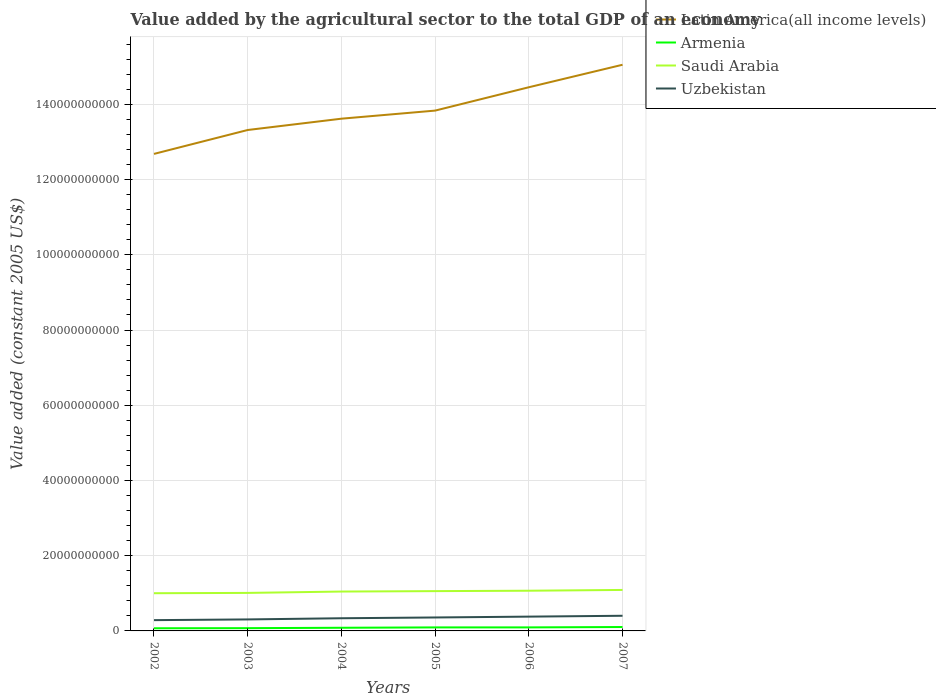Does the line corresponding to Saudi Arabia intersect with the line corresponding to Uzbekistan?
Your answer should be compact. No. Across all years, what is the maximum value added by the agricultural sector in Armenia?
Provide a succinct answer. 7.05e+08. In which year was the value added by the agricultural sector in Latin America(all income levels) maximum?
Your response must be concise. 2002. What is the total value added by the agricultural sector in Armenia in the graph?
Give a very brief answer. -9.48e+07. What is the difference between the highest and the second highest value added by the agricultural sector in Latin America(all income levels)?
Your answer should be compact. 2.37e+1. What is the difference between the highest and the lowest value added by the agricultural sector in Uzbekistan?
Ensure brevity in your answer.  3. Is the value added by the agricultural sector in Saudi Arabia strictly greater than the value added by the agricultural sector in Uzbekistan over the years?
Provide a short and direct response. No. What is the difference between two consecutive major ticks on the Y-axis?
Keep it short and to the point. 2.00e+1. Does the graph contain grids?
Your answer should be very brief. Yes. What is the title of the graph?
Keep it short and to the point. Value added by the agricultural sector to the total GDP of an economy. What is the label or title of the Y-axis?
Keep it short and to the point. Value added (constant 2005 US$). What is the Value added (constant 2005 US$) of Latin America(all income levels) in 2002?
Provide a short and direct response. 1.27e+11. What is the Value added (constant 2005 US$) in Armenia in 2002?
Provide a short and direct response. 7.05e+08. What is the Value added (constant 2005 US$) in Saudi Arabia in 2002?
Offer a very short reply. 1.00e+1. What is the Value added (constant 2005 US$) in Uzbekistan in 2002?
Offer a very short reply. 2.86e+09. What is the Value added (constant 2005 US$) of Latin America(all income levels) in 2003?
Give a very brief answer. 1.33e+11. What is the Value added (constant 2005 US$) in Armenia in 2003?
Your answer should be very brief. 7.34e+08. What is the Value added (constant 2005 US$) of Saudi Arabia in 2003?
Offer a terse response. 1.01e+1. What is the Value added (constant 2005 US$) of Uzbekistan in 2003?
Your answer should be compact. 3.06e+09. What is the Value added (constant 2005 US$) in Latin America(all income levels) in 2004?
Your answer should be compact. 1.36e+11. What is the Value added (constant 2005 US$) of Armenia in 2004?
Your response must be concise. 8.41e+08. What is the Value added (constant 2005 US$) in Saudi Arabia in 2004?
Offer a terse response. 1.05e+1. What is the Value added (constant 2005 US$) of Uzbekistan in 2004?
Provide a short and direct response. 3.37e+09. What is the Value added (constant 2005 US$) in Latin America(all income levels) in 2005?
Give a very brief answer. 1.38e+11. What is the Value added (constant 2005 US$) of Armenia in 2005?
Ensure brevity in your answer.  9.36e+08. What is the Value added (constant 2005 US$) of Saudi Arabia in 2005?
Provide a succinct answer. 1.06e+1. What is the Value added (constant 2005 US$) in Uzbekistan in 2005?
Keep it short and to the point. 3.58e+09. What is the Value added (constant 2005 US$) in Latin America(all income levels) in 2006?
Provide a short and direct response. 1.45e+11. What is the Value added (constant 2005 US$) in Armenia in 2006?
Give a very brief answer. 9.40e+08. What is the Value added (constant 2005 US$) in Saudi Arabia in 2006?
Provide a short and direct response. 1.07e+1. What is the Value added (constant 2005 US$) of Uzbekistan in 2006?
Give a very brief answer. 3.80e+09. What is the Value added (constant 2005 US$) in Latin America(all income levels) in 2007?
Give a very brief answer. 1.51e+11. What is the Value added (constant 2005 US$) of Armenia in 2007?
Your response must be concise. 1.04e+09. What is the Value added (constant 2005 US$) of Saudi Arabia in 2007?
Your answer should be compact. 1.09e+1. What is the Value added (constant 2005 US$) of Uzbekistan in 2007?
Give a very brief answer. 4.03e+09. Across all years, what is the maximum Value added (constant 2005 US$) in Latin America(all income levels)?
Your answer should be very brief. 1.51e+11. Across all years, what is the maximum Value added (constant 2005 US$) in Armenia?
Offer a terse response. 1.04e+09. Across all years, what is the maximum Value added (constant 2005 US$) of Saudi Arabia?
Give a very brief answer. 1.09e+1. Across all years, what is the maximum Value added (constant 2005 US$) in Uzbekistan?
Provide a short and direct response. 4.03e+09. Across all years, what is the minimum Value added (constant 2005 US$) in Latin America(all income levels)?
Offer a very short reply. 1.27e+11. Across all years, what is the minimum Value added (constant 2005 US$) in Armenia?
Give a very brief answer. 7.05e+08. Across all years, what is the minimum Value added (constant 2005 US$) in Saudi Arabia?
Keep it short and to the point. 1.00e+1. Across all years, what is the minimum Value added (constant 2005 US$) of Uzbekistan?
Ensure brevity in your answer.  2.86e+09. What is the total Value added (constant 2005 US$) of Latin America(all income levels) in the graph?
Give a very brief answer. 8.30e+11. What is the total Value added (constant 2005 US$) in Armenia in the graph?
Your response must be concise. 5.19e+09. What is the total Value added (constant 2005 US$) in Saudi Arabia in the graph?
Your answer should be very brief. 6.28e+1. What is the total Value added (constant 2005 US$) of Uzbekistan in the graph?
Provide a short and direct response. 2.07e+1. What is the difference between the Value added (constant 2005 US$) in Latin America(all income levels) in 2002 and that in 2003?
Keep it short and to the point. -6.36e+09. What is the difference between the Value added (constant 2005 US$) in Armenia in 2002 and that in 2003?
Your response must be concise. -2.97e+07. What is the difference between the Value added (constant 2005 US$) in Saudi Arabia in 2002 and that in 2003?
Keep it short and to the point. -8.17e+07. What is the difference between the Value added (constant 2005 US$) of Uzbekistan in 2002 and that in 2003?
Keep it short and to the point. -1.95e+08. What is the difference between the Value added (constant 2005 US$) in Latin America(all income levels) in 2002 and that in 2004?
Offer a terse response. -9.36e+09. What is the difference between the Value added (constant 2005 US$) in Armenia in 2002 and that in 2004?
Your answer should be compact. -1.36e+08. What is the difference between the Value added (constant 2005 US$) of Saudi Arabia in 2002 and that in 2004?
Keep it short and to the point. -4.44e+08. What is the difference between the Value added (constant 2005 US$) in Uzbekistan in 2002 and that in 2004?
Your response must be concise. -5.04e+08. What is the difference between the Value added (constant 2005 US$) of Latin America(all income levels) in 2002 and that in 2005?
Make the answer very short. -1.15e+1. What is the difference between the Value added (constant 2005 US$) in Armenia in 2002 and that in 2005?
Offer a very short reply. -2.31e+08. What is the difference between the Value added (constant 2005 US$) of Saudi Arabia in 2002 and that in 2005?
Provide a succinct answer. -5.55e+08. What is the difference between the Value added (constant 2005 US$) in Uzbekistan in 2002 and that in 2005?
Give a very brief answer. -7.13e+08. What is the difference between the Value added (constant 2005 US$) of Latin America(all income levels) in 2002 and that in 2006?
Your answer should be compact. -1.77e+1. What is the difference between the Value added (constant 2005 US$) of Armenia in 2002 and that in 2006?
Your answer should be compact. -2.36e+08. What is the difference between the Value added (constant 2005 US$) in Saudi Arabia in 2002 and that in 2006?
Provide a succinct answer. -6.62e+08. What is the difference between the Value added (constant 2005 US$) in Uzbekistan in 2002 and that in 2006?
Give a very brief answer. -9.34e+08. What is the difference between the Value added (constant 2005 US$) in Latin America(all income levels) in 2002 and that in 2007?
Offer a terse response. -2.37e+1. What is the difference between the Value added (constant 2005 US$) in Armenia in 2002 and that in 2007?
Your answer should be compact. -3.33e+08. What is the difference between the Value added (constant 2005 US$) of Saudi Arabia in 2002 and that in 2007?
Provide a short and direct response. -8.70e+08. What is the difference between the Value added (constant 2005 US$) of Uzbekistan in 2002 and that in 2007?
Give a very brief answer. -1.17e+09. What is the difference between the Value added (constant 2005 US$) of Latin America(all income levels) in 2003 and that in 2004?
Keep it short and to the point. -3.01e+09. What is the difference between the Value added (constant 2005 US$) in Armenia in 2003 and that in 2004?
Provide a short and direct response. -1.07e+08. What is the difference between the Value added (constant 2005 US$) in Saudi Arabia in 2003 and that in 2004?
Your answer should be compact. -3.63e+08. What is the difference between the Value added (constant 2005 US$) of Uzbekistan in 2003 and that in 2004?
Your answer should be very brief. -3.09e+08. What is the difference between the Value added (constant 2005 US$) of Latin America(all income levels) in 2003 and that in 2005?
Give a very brief answer. -5.16e+09. What is the difference between the Value added (constant 2005 US$) of Armenia in 2003 and that in 2005?
Keep it short and to the point. -2.02e+08. What is the difference between the Value added (constant 2005 US$) in Saudi Arabia in 2003 and that in 2005?
Offer a very short reply. -4.74e+08. What is the difference between the Value added (constant 2005 US$) of Uzbekistan in 2003 and that in 2005?
Keep it short and to the point. -5.18e+08. What is the difference between the Value added (constant 2005 US$) of Latin America(all income levels) in 2003 and that in 2006?
Provide a short and direct response. -1.14e+1. What is the difference between the Value added (constant 2005 US$) of Armenia in 2003 and that in 2006?
Your answer should be very brief. -2.06e+08. What is the difference between the Value added (constant 2005 US$) of Saudi Arabia in 2003 and that in 2006?
Offer a very short reply. -5.80e+08. What is the difference between the Value added (constant 2005 US$) of Uzbekistan in 2003 and that in 2006?
Make the answer very short. -7.40e+08. What is the difference between the Value added (constant 2005 US$) of Latin America(all income levels) in 2003 and that in 2007?
Offer a very short reply. -1.73e+1. What is the difference between the Value added (constant 2005 US$) of Armenia in 2003 and that in 2007?
Keep it short and to the point. -3.03e+08. What is the difference between the Value added (constant 2005 US$) in Saudi Arabia in 2003 and that in 2007?
Your answer should be compact. -7.89e+08. What is the difference between the Value added (constant 2005 US$) of Uzbekistan in 2003 and that in 2007?
Offer a very short reply. -9.71e+08. What is the difference between the Value added (constant 2005 US$) of Latin America(all income levels) in 2004 and that in 2005?
Your answer should be very brief. -2.15e+09. What is the difference between the Value added (constant 2005 US$) in Armenia in 2004 and that in 2005?
Provide a short and direct response. -9.48e+07. What is the difference between the Value added (constant 2005 US$) of Saudi Arabia in 2004 and that in 2005?
Give a very brief answer. -1.11e+08. What is the difference between the Value added (constant 2005 US$) of Uzbekistan in 2004 and that in 2005?
Provide a short and direct response. -2.09e+08. What is the difference between the Value added (constant 2005 US$) in Latin America(all income levels) in 2004 and that in 2006?
Offer a very short reply. -8.36e+09. What is the difference between the Value added (constant 2005 US$) of Armenia in 2004 and that in 2006?
Keep it short and to the point. -9.94e+07. What is the difference between the Value added (constant 2005 US$) in Saudi Arabia in 2004 and that in 2006?
Offer a very short reply. -2.18e+08. What is the difference between the Value added (constant 2005 US$) of Uzbekistan in 2004 and that in 2006?
Your answer should be very brief. -4.31e+08. What is the difference between the Value added (constant 2005 US$) of Latin America(all income levels) in 2004 and that in 2007?
Your answer should be compact. -1.43e+1. What is the difference between the Value added (constant 2005 US$) of Armenia in 2004 and that in 2007?
Provide a succinct answer. -1.96e+08. What is the difference between the Value added (constant 2005 US$) in Saudi Arabia in 2004 and that in 2007?
Keep it short and to the point. -4.26e+08. What is the difference between the Value added (constant 2005 US$) of Uzbekistan in 2004 and that in 2007?
Your answer should be compact. -6.62e+08. What is the difference between the Value added (constant 2005 US$) of Latin America(all income levels) in 2005 and that in 2006?
Your response must be concise. -6.21e+09. What is the difference between the Value added (constant 2005 US$) in Armenia in 2005 and that in 2006?
Ensure brevity in your answer.  -4.53e+06. What is the difference between the Value added (constant 2005 US$) in Saudi Arabia in 2005 and that in 2006?
Offer a very short reply. -1.07e+08. What is the difference between the Value added (constant 2005 US$) in Uzbekistan in 2005 and that in 2006?
Provide a short and direct response. -2.22e+08. What is the difference between the Value added (constant 2005 US$) in Latin America(all income levels) in 2005 and that in 2007?
Your answer should be very brief. -1.22e+1. What is the difference between the Value added (constant 2005 US$) of Armenia in 2005 and that in 2007?
Ensure brevity in your answer.  -1.01e+08. What is the difference between the Value added (constant 2005 US$) in Saudi Arabia in 2005 and that in 2007?
Offer a terse response. -3.15e+08. What is the difference between the Value added (constant 2005 US$) in Uzbekistan in 2005 and that in 2007?
Provide a short and direct response. -4.53e+08. What is the difference between the Value added (constant 2005 US$) of Latin America(all income levels) in 2006 and that in 2007?
Offer a terse response. -5.98e+09. What is the difference between the Value added (constant 2005 US$) of Armenia in 2006 and that in 2007?
Your answer should be compact. -9.69e+07. What is the difference between the Value added (constant 2005 US$) in Saudi Arabia in 2006 and that in 2007?
Provide a succinct answer. -2.08e+08. What is the difference between the Value added (constant 2005 US$) in Uzbekistan in 2006 and that in 2007?
Your answer should be compact. -2.32e+08. What is the difference between the Value added (constant 2005 US$) in Latin America(all income levels) in 2002 and the Value added (constant 2005 US$) in Armenia in 2003?
Make the answer very short. 1.26e+11. What is the difference between the Value added (constant 2005 US$) of Latin America(all income levels) in 2002 and the Value added (constant 2005 US$) of Saudi Arabia in 2003?
Offer a terse response. 1.17e+11. What is the difference between the Value added (constant 2005 US$) in Latin America(all income levels) in 2002 and the Value added (constant 2005 US$) in Uzbekistan in 2003?
Keep it short and to the point. 1.24e+11. What is the difference between the Value added (constant 2005 US$) in Armenia in 2002 and the Value added (constant 2005 US$) in Saudi Arabia in 2003?
Make the answer very short. -9.40e+09. What is the difference between the Value added (constant 2005 US$) in Armenia in 2002 and the Value added (constant 2005 US$) in Uzbekistan in 2003?
Your answer should be compact. -2.35e+09. What is the difference between the Value added (constant 2005 US$) in Saudi Arabia in 2002 and the Value added (constant 2005 US$) in Uzbekistan in 2003?
Offer a very short reply. 6.96e+09. What is the difference between the Value added (constant 2005 US$) in Latin America(all income levels) in 2002 and the Value added (constant 2005 US$) in Armenia in 2004?
Ensure brevity in your answer.  1.26e+11. What is the difference between the Value added (constant 2005 US$) of Latin America(all income levels) in 2002 and the Value added (constant 2005 US$) of Saudi Arabia in 2004?
Provide a succinct answer. 1.16e+11. What is the difference between the Value added (constant 2005 US$) of Latin America(all income levels) in 2002 and the Value added (constant 2005 US$) of Uzbekistan in 2004?
Provide a short and direct response. 1.23e+11. What is the difference between the Value added (constant 2005 US$) in Armenia in 2002 and the Value added (constant 2005 US$) in Saudi Arabia in 2004?
Ensure brevity in your answer.  -9.76e+09. What is the difference between the Value added (constant 2005 US$) of Armenia in 2002 and the Value added (constant 2005 US$) of Uzbekistan in 2004?
Your answer should be compact. -2.66e+09. What is the difference between the Value added (constant 2005 US$) in Saudi Arabia in 2002 and the Value added (constant 2005 US$) in Uzbekistan in 2004?
Keep it short and to the point. 6.66e+09. What is the difference between the Value added (constant 2005 US$) in Latin America(all income levels) in 2002 and the Value added (constant 2005 US$) in Armenia in 2005?
Provide a short and direct response. 1.26e+11. What is the difference between the Value added (constant 2005 US$) of Latin America(all income levels) in 2002 and the Value added (constant 2005 US$) of Saudi Arabia in 2005?
Make the answer very short. 1.16e+11. What is the difference between the Value added (constant 2005 US$) of Latin America(all income levels) in 2002 and the Value added (constant 2005 US$) of Uzbekistan in 2005?
Offer a terse response. 1.23e+11. What is the difference between the Value added (constant 2005 US$) in Armenia in 2002 and the Value added (constant 2005 US$) in Saudi Arabia in 2005?
Keep it short and to the point. -9.87e+09. What is the difference between the Value added (constant 2005 US$) of Armenia in 2002 and the Value added (constant 2005 US$) of Uzbekistan in 2005?
Offer a terse response. -2.87e+09. What is the difference between the Value added (constant 2005 US$) in Saudi Arabia in 2002 and the Value added (constant 2005 US$) in Uzbekistan in 2005?
Your answer should be compact. 6.45e+09. What is the difference between the Value added (constant 2005 US$) of Latin America(all income levels) in 2002 and the Value added (constant 2005 US$) of Armenia in 2006?
Offer a very short reply. 1.26e+11. What is the difference between the Value added (constant 2005 US$) of Latin America(all income levels) in 2002 and the Value added (constant 2005 US$) of Saudi Arabia in 2006?
Offer a terse response. 1.16e+11. What is the difference between the Value added (constant 2005 US$) in Latin America(all income levels) in 2002 and the Value added (constant 2005 US$) in Uzbekistan in 2006?
Ensure brevity in your answer.  1.23e+11. What is the difference between the Value added (constant 2005 US$) in Armenia in 2002 and the Value added (constant 2005 US$) in Saudi Arabia in 2006?
Your answer should be very brief. -9.98e+09. What is the difference between the Value added (constant 2005 US$) in Armenia in 2002 and the Value added (constant 2005 US$) in Uzbekistan in 2006?
Your response must be concise. -3.09e+09. What is the difference between the Value added (constant 2005 US$) in Saudi Arabia in 2002 and the Value added (constant 2005 US$) in Uzbekistan in 2006?
Give a very brief answer. 6.23e+09. What is the difference between the Value added (constant 2005 US$) of Latin America(all income levels) in 2002 and the Value added (constant 2005 US$) of Armenia in 2007?
Offer a terse response. 1.26e+11. What is the difference between the Value added (constant 2005 US$) of Latin America(all income levels) in 2002 and the Value added (constant 2005 US$) of Saudi Arabia in 2007?
Provide a short and direct response. 1.16e+11. What is the difference between the Value added (constant 2005 US$) of Latin America(all income levels) in 2002 and the Value added (constant 2005 US$) of Uzbekistan in 2007?
Offer a very short reply. 1.23e+11. What is the difference between the Value added (constant 2005 US$) of Armenia in 2002 and the Value added (constant 2005 US$) of Saudi Arabia in 2007?
Make the answer very short. -1.02e+1. What is the difference between the Value added (constant 2005 US$) of Armenia in 2002 and the Value added (constant 2005 US$) of Uzbekistan in 2007?
Provide a short and direct response. -3.33e+09. What is the difference between the Value added (constant 2005 US$) of Saudi Arabia in 2002 and the Value added (constant 2005 US$) of Uzbekistan in 2007?
Provide a succinct answer. 5.99e+09. What is the difference between the Value added (constant 2005 US$) in Latin America(all income levels) in 2003 and the Value added (constant 2005 US$) in Armenia in 2004?
Your answer should be compact. 1.32e+11. What is the difference between the Value added (constant 2005 US$) in Latin America(all income levels) in 2003 and the Value added (constant 2005 US$) in Saudi Arabia in 2004?
Make the answer very short. 1.23e+11. What is the difference between the Value added (constant 2005 US$) of Latin America(all income levels) in 2003 and the Value added (constant 2005 US$) of Uzbekistan in 2004?
Offer a terse response. 1.30e+11. What is the difference between the Value added (constant 2005 US$) of Armenia in 2003 and the Value added (constant 2005 US$) of Saudi Arabia in 2004?
Your answer should be very brief. -9.73e+09. What is the difference between the Value added (constant 2005 US$) in Armenia in 2003 and the Value added (constant 2005 US$) in Uzbekistan in 2004?
Offer a terse response. -2.63e+09. What is the difference between the Value added (constant 2005 US$) in Saudi Arabia in 2003 and the Value added (constant 2005 US$) in Uzbekistan in 2004?
Your answer should be compact. 6.74e+09. What is the difference between the Value added (constant 2005 US$) of Latin America(all income levels) in 2003 and the Value added (constant 2005 US$) of Armenia in 2005?
Offer a very short reply. 1.32e+11. What is the difference between the Value added (constant 2005 US$) in Latin America(all income levels) in 2003 and the Value added (constant 2005 US$) in Saudi Arabia in 2005?
Make the answer very short. 1.23e+11. What is the difference between the Value added (constant 2005 US$) of Latin America(all income levels) in 2003 and the Value added (constant 2005 US$) of Uzbekistan in 2005?
Ensure brevity in your answer.  1.30e+11. What is the difference between the Value added (constant 2005 US$) in Armenia in 2003 and the Value added (constant 2005 US$) in Saudi Arabia in 2005?
Provide a succinct answer. -9.84e+09. What is the difference between the Value added (constant 2005 US$) of Armenia in 2003 and the Value added (constant 2005 US$) of Uzbekistan in 2005?
Provide a short and direct response. -2.84e+09. What is the difference between the Value added (constant 2005 US$) of Saudi Arabia in 2003 and the Value added (constant 2005 US$) of Uzbekistan in 2005?
Provide a short and direct response. 6.53e+09. What is the difference between the Value added (constant 2005 US$) of Latin America(all income levels) in 2003 and the Value added (constant 2005 US$) of Armenia in 2006?
Provide a succinct answer. 1.32e+11. What is the difference between the Value added (constant 2005 US$) of Latin America(all income levels) in 2003 and the Value added (constant 2005 US$) of Saudi Arabia in 2006?
Offer a terse response. 1.22e+11. What is the difference between the Value added (constant 2005 US$) of Latin America(all income levels) in 2003 and the Value added (constant 2005 US$) of Uzbekistan in 2006?
Your answer should be very brief. 1.29e+11. What is the difference between the Value added (constant 2005 US$) in Armenia in 2003 and the Value added (constant 2005 US$) in Saudi Arabia in 2006?
Make the answer very short. -9.95e+09. What is the difference between the Value added (constant 2005 US$) of Armenia in 2003 and the Value added (constant 2005 US$) of Uzbekistan in 2006?
Provide a succinct answer. -3.06e+09. What is the difference between the Value added (constant 2005 US$) in Saudi Arabia in 2003 and the Value added (constant 2005 US$) in Uzbekistan in 2006?
Your answer should be very brief. 6.31e+09. What is the difference between the Value added (constant 2005 US$) of Latin America(all income levels) in 2003 and the Value added (constant 2005 US$) of Armenia in 2007?
Make the answer very short. 1.32e+11. What is the difference between the Value added (constant 2005 US$) of Latin America(all income levels) in 2003 and the Value added (constant 2005 US$) of Saudi Arabia in 2007?
Make the answer very short. 1.22e+11. What is the difference between the Value added (constant 2005 US$) of Latin America(all income levels) in 2003 and the Value added (constant 2005 US$) of Uzbekistan in 2007?
Your response must be concise. 1.29e+11. What is the difference between the Value added (constant 2005 US$) of Armenia in 2003 and the Value added (constant 2005 US$) of Saudi Arabia in 2007?
Your answer should be very brief. -1.02e+1. What is the difference between the Value added (constant 2005 US$) in Armenia in 2003 and the Value added (constant 2005 US$) in Uzbekistan in 2007?
Provide a short and direct response. -3.30e+09. What is the difference between the Value added (constant 2005 US$) of Saudi Arabia in 2003 and the Value added (constant 2005 US$) of Uzbekistan in 2007?
Provide a succinct answer. 6.08e+09. What is the difference between the Value added (constant 2005 US$) in Latin America(all income levels) in 2004 and the Value added (constant 2005 US$) in Armenia in 2005?
Keep it short and to the point. 1.35e+11. What is the difference between the Value added (constant 2005 US$) of Latin America(all income levels) in 2004 and the Value added (constant 2005 US$) of Saudi Arabia in 2005?
Keep it short and to the point. 1.26e+11. What is the difference between the Value added (constant 2005 US$) in Latin America(all income levels) in 2004 and the Value added (constant 2005 US$) in Uzbekistan in 2005?
Ensure brevity in your answer.  1.33e+11. What is the difference between the Value added (constant 2005 US$) in Armenia in 2004 and the Value added (constant 2005 US$) in Saudi Arabia in 2005?
Provide a succinct answer. -9.74e+09. What is the difference between the Value added (constant 2005 US$) of Armenia in 2004 and the Value added (constant 2005 US$) of Uzbekistan in 2005?
Offer a very short reply. -2.74e+09. What is the difference between the Value added (constant 2005 US$) of Saudi Arabia in 2004 and the Value added (constant 2005 US$) of Uzbekistan in 2005?
Provide a succinct answer. 6.89e+09. What is the difference between the Value added (constant 2005 US$) in Latin America(all income levels) in 2004 and the Value added (constant 2005 US$) in Armenia in 2006?
Your answer should be compact. 1.35e+11. What is the difference between the Value added (constant 2005 US$) of Latin America(all income levels) in 2004 and the Value added (constant 2005 US$) of Saudi Arabia in 2006?
Ensure brevity in your answer.  1.25e+11. What is the difference between the Value added (constant 2005 US$) of Latin America(all income levels) in 2004 and the Value added (constant 2005 US$) of Uzbekistan in 2006?
Ensure brevity in your answer.  1.32e+11. What is the difference between the Value added (constant 2005 US$) in Armenia in 2004 and the Value added (constant 2005 US$) in Saudi Arabia in 2006?
Provide a succinct answer. -9.85e+09. What is the difference between the Value added (constant 2005 US$) of Armenia in 2004 and the Value added (constant 2005 US$) of Uzbekistan in 2006?
Ensure brevity in your answer.  -2.96e+09. What is the difference between the Value added (constant 2005 US$) of Saudi Arabia in 2004 and the Value added (constant 2005 US$) of Uzbekistan in 2006?
Ensure brevity in your answer.  6.67e+09. What is the difference between the Value added (constant 2005 US$) of Latin America(all income levels) in 2004 and the Value added (constant 2005 US$) of Armenia in 2007?
Make the answer very short. 1.35e+11. What is the difference between the Value added (constant 2005 US$) of Latin America(all income levels) in 2004 and the Value added (constant 2005 US$) of Saudi Arabia in 2007?
Your answer should be very brief. 1.25e+11. What is the difference between the Value added (constant 2005 US$) in Latin America(all income levels) in 2004 and the Value added (constant 2005 US$) in Uzbekistan in 2007?
Keep it short and to the point. 1.32e+11. What is the difference between the Value added (constant 2005 US$) in Armenia in 2004 and the Value added (constant 2005 US$) in Saudi Arabia in 2007?
Provide a short and direct response. -1.01e+1. What is the difference between the Value added (constant 2005 US$) in Armenia in 2004 and the Value added (constant 2005 US$) in Uzbekistan in 2007?
Your answer should be compact. -3.19e+09. What is the difference between the Value added (constant 2005 US$) of Saudi Arabia in 2004 and the Value added (constant 2005 US$) of Uzbekistan in 2007?
Your response must be concise. 6.44e+09. What is the difference between the Value added (constant 2005 US$) of Latin America(all income levels) in 2005 and the Value added (constant 2005 US$) of Armenia in 2006?
Offer a very short reply. 1.37e+11. What is the difference between the Value added (constant 2005 US$) in Latin America(all income levels) in 2005 and the Value added (constant 2005 US$) in Saudi Arabia in 2006?
Give a very brief answer. 1.28e+11. What is the difference between the Value added (constant 2005 US$) of Latin America(all income levels) in 2005 and the Value added (constant 2005 US$) of Uzbekistan in 2006?
Offer a terse response. 1.35e+11. What is the difference between the Value added (constant 2005 US$) of Armenia in 2005 and the Value added (constant 2005 US$) of Saudi Arabia in 2006?
Your response must be concise. -9.75e+09. What is the difference between the Value added (constant 2005 US$) in Armenia in 2005 and the Value added (constant 2005 US$) in Uzbekistan in 2006?
Offer a very short reply. -2.86e+09. What is the difference between the Value added (constant 2005 US$) of Saudi Arabia in 2005 and the Value added (constant 2005 US$) of Uzbekistan in 2006?
Give a very brief answer. 6.78e+09. What is the difference between the Value added (constant 2005 US$) in Latin America(all income levels) in 2005 and the Value added (constant 2005 US$) in Armenia in 2007?
Keep it short and to the point. 1.37e+11. What is the difference between the Value added (constant 2005 US$) in Latin America(all income levels) in 2005 and the Value added (constant 2005 US$) in Saudi Arabia in 2007?
Offer a very short reply. 1.27e+11. What is the difference between the Value added (constant 2005 US$) in Latin America(all income levels) in 2005 and the Value added (constant 2005 US$) in Uzbekistan in 2007?
Provide a succinct answer. 1.34e+11. What is the difference between the Value added (constant 2005 US$) of Armenia in 2005 and the Value added (constant 2005 US$) of Saudi Arabia in 2007?
Give a very brief answer. -9.96e+09. What is the difference between the Value added (constant 2005 US$) in Armenia in 2005 and the Value added (constant 2005 US$) in Uzbekistan in 2007?
Your answer should be compact. -3.09e+09. What is the difference between the Value added (constant 2005 US$) in Saudi Arabia in 2005 and the Value added (constant 2005 US$) in Uzbekistan in 2007?
Offer a very short reply. 6.55e+09. What is the difference between the Value added (constant 2005 US$) in Latin America(all income levels) in 2006 and the Value added (constant 2005 US$) in Armenia in 2007?
Offer a very short reply. 1.43e+11. What is the difference between the Value added (constant 2005 US$) in Latin America(all income levels) in 2006 and the Value added (constant 2005 US$) in Saudi Arabia in 2007?
Your answer should be compact. 1.34e+11. What is the difference between the Value added (constant 2005 US$) of Latin America(all income levels) in 2006 and the Value added (constant 2005 US$) of Uzbekistan in 2007?
Offer a very short reply. 1.41e+11. What is the difference between the Value added (constant 2005 US$) of Armenia in 2006 and the Value added (constant 2005 US$) of Saudi Arabia in 2007?
Make the answer very short. -9.95e+09. What is the difference between the Value added (constant 2005 US$) in Armenia in 2006 and the Value added (constant 2005 US$) in Uzbekistan in 2007?
Provide a short and direct response. -3.09e+09. What is the difference between the Value added (constant 2005 US$) of Saudi Arabia in 2006 and the Value added (constant 2005 US$) of Uzbekistan in 2007?
Keep it short and to the point. 6.66e+09. What is the average Value added (constant 2005 US$) of Latin America(all income levels) per year?
Keep it short and to the point. 1.38e+11. What is the average Value added (constant 2005 US$) of Armenia per year?
Provide a short and direct response. 8.65e+08. What is the average Value added (constant 2005 US$) of Saudi Arabia per year?
Provide a short and direct response. 1.05e+1. What is the average Value added (constant 2005 US$) of Uzbekistan per year?
Offer a terse response. 3.45e+09. In the year 2002, what is the difference between the Value added (constant 2005 US$) of Latin America(all income levels) and Value added (constant 2005 US$) of Armenia?
Offer a very short reply. 1.26e+11. In the year 2002, what is the difference between the Value added (constant 2005 US$) in Latin America(all income levels) and Value added (constant 2005 US$) in Saudi Arabia?
Provide a succinct answer. 1.17e+11. In the year 2002, what is the difference between the Value added (constant 2005 US$) of Latin America(all income levels) and Value added (constant 2005 US$) of Uzbekistan?
Give a very brief answer. 1.24e+11. In the year 2002, what is the difference between the Value added (constant 2005 US$) of Armenia and Value added (constant 2005 US$) of Saudi Arabia?
Offer a very short reply. -9.32e+09. In the year 2002, what is the difference between the Value added (constant 2005 US$) of Armenia and Value added (constant 2005 US$) of Uzbekistan?
Provide a short and direct response. -2.16e+09. In the year 2002, what is the difference between the Value added (constant 2005 US$) in Saudi Arabia and Value added (constant 2005 US$) in Uzbekistan?
Keep it short and to the point. 7.16e+09. In the year 2003, what is the difference between the Value added (constant 2005 US$) of Latin America(all income levels) and Value added (constant 2005 US$) of Armenia?
Provide a short and direct response. 1.32e+11. In the year 2003, what is the difference between the Value added (constant 2005 US$) of Latin America(all income levels) and Value added (constant 2005 US$) of Saudi Arabia?
Make the answer very short. 1.23e+11. In the year 2003, what is the difference between the Value added (constant 2005 US$) of Latin America(all income levels) and Value added (constant 2005 US$) of Uzbekistan?
Your response must be concise. 1.30e+11. In the year 2003, what is the difference between the Value added (constant 2005 US$) of Armenia and Value added (constant 2005 US$) of Saudi Arabia?
Provide a short and direct response. -9.37e+09. In the year 2003, what is the difference between the Value added (constant 2005 US$) of Armenia and Value added (constant 2005 US$) of Uzbekistan?
Provide a short and direct response. -2.32e+09. In the year 2003, what is the difference between the Value added (constant 2005 US$) in Saudi Arabia and Value added (constant 2005 US$) in Uzbekistan?
Your response must be concise. 7.05e+09. In the year 2004, what is the difference between the Value added (constant 2005 US$) of Latin America(all income levels) and Value added (constant 2005 US$) of Armenia?
Ensure brevity in your answer.  1.35e+11. In the year 2004, what is the difference between the Value added (constant 2005 US$) in Latin America(all income levels) and Value added (constant 2005 US$) in Saudi Arabia?
Ensure brevity in your answer.  1.26e+11. In the year 2004, what is the difference between the Value added (constant 2005 US$) of Latin America(all income levels) and Value added (constant 2005 US$) of Uzbekistan?
Provide a succinct answer. 1.33e+11. In the year 2004, what is the difference between the Value added (constant 2005 US$) in Armenia and Value added (constant 2005 US$) in Saudi Arabia?
Keep it short and to the point. -9.63e+09. In the year 2004, what is the difference between the Value added (constant 2005 US$) of Armenia and Value added (constant 2005 US$) of Uzbekistan?
Provide a short and direct response. -2.53e+09. In the year 2004, what is the difference between the Value added (constant 2005 US$) of Saudi Arabia and Value added (constant 2005 US$) of Uzbekistan?
Offer a terse response. 7.10e+09. In the year 2005, what is the difference between the Value added (constant 2005 US$) of Latin America(all income levels) and Value added (constant 2005 US$) of Armenia?
Ensure brevity in your answer.  1.37e+11. In the year 2005, what is the difference between the Value added (constant 2005 US$) of Latin America(all income levels) and Value added (constant 2005 US$) of Saudi Arabia?
Make the answer very short. 1.28e+11. In the year 2005, what is the difference between the Value added (constant 2005 US$) of Latin America(all income levels) and Value added (constant 2005 US$) of Uzbekistan?
Your answer should be very brief. 1.35e+11. In the year 2005, what is the difference between the Value added (constant 2005 US$) in Armenia and Value added (constant 2005 US$) in Saudi Arabia?
Provide a succinct answer. -9.64e+09. In the year 2005, what is the difference between the Value added (constant 2005 US$) of Armenia and Value added (constant 2005 US$) of Uzbekistan?
Your answer should be very brief. -2.64e+09. In the year 2005, what is the difference between the Value added (constant 2005 US$) in Saudi Arabia and Value added (constant 2005 US$) in Uzbekistan?
Provide a succinct answer. 7.00e+09. In the year 2006, what is the difference between the Value added (constant 2005 US$) of Latin America(all income levels) and Value added (constant 2005 US$) of Armenia?
Keep it short and to the point. 1.44e+11. In the year 2006, what is the difference between the Value added (constant 2005 US$) of Latin America(all income levels) and Value added (constant 2005 US$) of Saudi Arabia?
Provide a succinct answer. 1.34e+11. In the year 2006, what is the difference between the Value added (constant 2005 US$) in Latin America(all income levels) and Value added (constant 2005 US$) in Uzbekistan?
Your response must be concise. 1.41e+11. In the year 2006, what is the difference between the Value added (constant 2005 US$) of Armenia and Value added (constant 2005 US$) of Saudi Arabia?
Provide a short and direct response. -9.75e+09. In the year 2006, what is the difference between the Value added (constant 2005 US$) in Armenia and Value added (constant 2005 US$) in Uzbekistan?
Keep it short and to the point. -2.86e+09. In the year 2006, what is the difference between the Value added (constant 2005 US$) in Saudi Arabia and Value added (constant 2005 US$) in Uzbekistan?
Your answer should be compact. 6.89e+09. In the year 2007, what is the difference between the Value added (constant 2005 US$) in Latin America(all income levels) and Value added (constant 2005 US$) in Armenia?
Give a very brief answer. 1.49e+11. In the year 2007, what is the difference between the Value added (constant 2005 US$) of Latin America(all income levels) and Value added (constant 2005 US$) of Saudi Arabia?
Offer a terse response. 1.40e+11. In the year 2007, what is the difference between the Value added (constant 2005 US$) of Latin America(all income levels) and Value added (constant 2005 US$) of Uzbekistan?
Give a very brief answer. 1.46e+11. In the year 2007, what is the difference between the Value added (constant 2005 US$) of Armenia and Value added (constant 2005 US$) of Saudi Arabia?
Give a very brief answer. -9.86e+09. In the year 2007, what is the difference between the Value added (constant 2005 US$) of Armenia and Value added (constant 2005 US$) of Uzbekistan?
Offer a terse response. -2.99e+09. In the year 2007, what is the difference between the Value added (constant 2005 US$) in Saudi Arabia and Value added (constant 2005 US$) in Uzbekistan?
Keep it short and to the point. 6.86e+09. What is the ratio of the Value added (constant 2005 US$) of Latin America(all income levels) in 2002 to that in 2003?
Your response must be concise. 0.95. What is the ratio of the Value added (constant 2005 US$) in Armenia in 2002 to that in 2003?
Your answer should be very brief. 0.96. What is the ratio of the Value added (constant 2005 US$) of Saudi Arabia in 2002 to that in 2003?
Make the answer very short. 0.99. What is the ratio of the Value added (constant 2005 US$) in Uzbekistan in 2002 to that in 2003?
Offer a very short reply. 0.94. What is the ratio of the Value added (constant 2005 US$) in Latin America(all income levels) in 2002 to that in 2004?
Ensure brevity in your answer.  0.93. What is the ratio of the Value added (constant 2005 US$) of Armenia in 2002 to that in 2004?
Offer a terse response. 0.84. What is the ratio of the Value added (constant 2005 US$) of Saudi Arabia in 2002 to that in 2004?
Offer a terse response. 0.96. What is the ratio of the Value added (constant 2005 US$) in Uzbekistan in 2002 to that in 2004?
Your response must be concise. 0.85. What is the ratio of the Value added (constant 2005 US$) in Latin America(all income levels) in 2002 to that in 2005?
Offer a very short reply. 0.92. What is the ratio of the Value added (constant 2005 US$) of Armenia in 2002 to that in 2005?
Your answer should be very brief. 0.75. What is the ratio of the Value added (constant 2005 US$) of Saudi Arabia in 2002 to that in 2005?
Provide a short and direct response. 0.95. What is the ratio of the Value added (constant 2005 US$) of Uzbekistan in 2002 to that in 2005?
Offer a terse response. 0.8. What is the ratio of the Value added (constant 2005 US$) of Latin America(all income levels) in 2002 to that in 2006?
Offer a terse response. 0.88. What is the ratio of the Value added (constant 2005 US$) of Armenia in 2002 to that in 2006?
Offer a terse response. 0.75. What is the ratio of the Value added (constant 2005 US$) of Saudi Arabia in 2002 to that in 2006?
Give a very brief answer. 0.94. What is the ratio of the Value added (constant 2005 US$) of Uzbekistan in 2002 to that in 2006?
Provide a short and direct response. 0.75. What is the ratio of the Value added (constant 2005 US$) in Latin America(all income levels) in 2002 to that in 2007?
Ensure brevity in your answer.  0.84. What is the ratio of the Value added (constant 2005 US$) of Armenia in 2002 to that in 2007?
Your answer should be very brief. 0.68. What is the ratio of the Value added (constant 2005 US$) of Saudi Arabia in 2002 to that in 2007?
Your answer should be compact. 0.92. What is the ratio of the Value added (constant 2005 US$) of Uzbekistan in 2002 to that in 2007?
Provide a succinct answer. 0.71. What is the ratio of the Value added (constant 2005 US$) of Latin America(all income levels) in 2003 to that in 2004?
Give a very brief answer. 0.98. What is the ratio of the Value added (constant 2005 US$) in Armenia in 2003 to that in 2004?
Give a very brief answer. 0.87. What is the ratio of the Value added (constant 2005 US$) in Saudi Arabia in 2003 to that in 2004?
Your answer should be compact. 0.97. What is the ratio of the Value added (constant 2005 US$) in Uzbekistan in 2003 to that in 2004?
Provide a succinct answer. 0.91. What is the ratio of the Value added (constant 2005 US$) in Latin America(all income levels) in 2003 to that in 2005?
Keep it short and to the point. 0.96. What is the ratio of the Value added (constant 2005 US$) in Armenia in 2003 to that in 2005?
Your answer should be very brief. 0.78. What is the ratio of the Value added (constant 2005 US$) in Saudi Arabia in 2003 to that in 2005?
Your answer should be compact. 0.96. What is the ratio of the Value added (constant 2005 US$) in Uzbekistan in 2003 to that in 2005?
Provide a short and direct response. 0.86. What is the ratio of the Value added (constant 2005 US$) in Latin America(all income levels) in 2003 to that in 2006?
Your response must be concise. 0.92. What is the ratio of the Value added (constant 2005 US$) of Armenia in 2003 to that in 2006?
Make the answer very short. 0.78. What is the ratio of the Value added (constant 2005 US$) of Saudi Arabia in 2003 to that in 2006?
Your answer should be very brief. 0.95. What is the ratio of the Value added (constant 2005 US$) of Uzbekistan in 2003 to that in 2006?
Your response must be concise. 0.81. What is the ratio of the Value added (constant 2005 US$) of Latin America(all income levels) in 2003 to that in 2007?
Provide a short and direct response. 0.88. What is the ratio of the Value added (constant 2005 US$) in Armenia in 2003 to that in 2007?
Provide a succinct answer. 0.71. What is the ratio of the Value added (constant 2005 US$) of Saudi Arabia in 2003 to that in 2007?
Keep it short and to the point. 0.93. What is the ratio of the Value added (constant 2005 US$) of Uzbekistan in 2003 to that in 2007?
Ensure brevity in your answer.  0.76. What is the ratio of the Value added (constant 2005 US$) in Latin America(all income levels) in 2004 to that in 2005?
Your answer should be very brief. 0.98. What is the ratio of the Value added (constant 2005 US$) in Armenia in 2004 to that in 2005?
Your response must be concise. 0.9. What is the ratio of the Value added (constant 2005 US$) of Uzbekistan in 2004 to that in 2005?
Keep it short and to the point. 0.94. What is the ratio of the Value added (constant 2005 US$) in Latin America(all income levels) in 2004 to that in 2006?
Give a very brief answer. 0.94. What is the ratio of the Value added (constant 2005 US$) in Armenia in 2004 to that in 2006?
Your answer should be very brief. 0.89. What is the ratio of the Value added (constant 2005 US$) of Saudi Arabia in 2004 to that in 2006?
Provide a succinct answer. 0.98. What is the ratio of the Value added (constant 2005 US$) of Uzbekistan in 2004 to that in 2006?
Your answer should be compact. 0.89. What is the ratio of the Value added (constant 2005 US$) of Latin America(all income levels) in 2004 to that in 2007?
Make the answer very short. 0.9. What is the ratio of the Value added (constant 2005 US$) in Armenia in 2004 to that in 2007?
Offer a terse response. 0.81. What is the ratio of the Value added (constant 2005 US$) of Saudi Arabia in 2004 to that in 2007?
Provide a short and direct response. 0.96. What is the ratio of the Value added (constant 2005 US$) in Uzbekistan in 2004 to that in 2007?
Keep it short and to the point. 0.84. What is the ratio of the Value added (constant 2005 US$) of Latin America(all income levels) in 2005 to that in 2006?
Keep it short and to the point. 0.96. What is the ratio of the Value added (constant 2005 US$) in Armenia in 2005 to that in 2006?
Provide a short and direct response. 1. What is the ratio of the Value added (constant 2005 US$) in Saudi Arabia in 2005 to that in 2006?
Your response must be concise. 0.99. What is the ratio of the Value added (constant 2005 US$) in Uzbekistan in 2005 to that in 2006?
Give a very brief answer. 0.94. What is the ratio of the Value added (constant 2005 US$) of Latin America(all income levels) in 2005 to that in 2007?
Offer a very short reply. 0.92. What is the ratio of the Value added (constant 2005 US$) of Armenia in 2005 to that in 2007?
Offer a very short reply. 0.9. What is the ratio of the Value added (constant 2005 US$) in Saudi Arabia in 2005 to that in 2007?
Make the answer very short. 0.97. What is the ratio of the Value added (constant 2005 US$) in Uzbekistan in 2005 to that in 2007?
Offer a very short reply. 0.89. What is the ratio of the Value added (constant 2005 US$) of Latin America(all income levels) in 2006 to that in 2007?
Offer a very short reply. 0.96. What is the ratio of the Value added (constant 2005 US$) of Armenia in 2006 to that in 2007?
Your response must be concise. 0.91. What is the ratio of the Value added (constant 2005 US$) in Saudi Arabia in 2006 to that in 2007?
Your answer should be very brief. 0.98. What is the ratio of the Value added (constant 2005 US$) in Uzbekistan in 2006 to that in 2007?
Provide a short and direct response. 0.94. What is the difference between the highest and the second highest Value added (constant 2005 US$) in Latin America(all income levels)?
Your answer should be very brief. 5.98e+09. What is the difference between the highest and the second highest Value added (constant 2005 US$) of Armenia?
Your answer should be compact. 9.69e+07. What is the difference between the highest and the second highest Value added (constant 2005 US$) in Saudi Arabia?
Your answer should be very brief. 2.08e+08. What is the difference between the highest and the second highest Value added (constant 2005 US$) in Uzbekistan?
Provide a short and direct response. 2.32e+08. What is the difference between the highest and the lowest Value added (constant 2005 US$) in Latin America(all income levels)?
Ensure brevity in your answer.  2.37e+1. What is the difference between the highest and the lowest Value added (constant 2005 US$) in Armenia?
Give a very brief answer. 3.33e+08. What is the difference between the highest and the lowest Value added (constant 2005 US$) of Saudi Arabia?
Make the answer very short. 8.70e+08. What is the difference between the highest and the lowest Value added (constant 2005 US$) of Uzbekistan?
Your answer should be compact. 1.17e+09. 